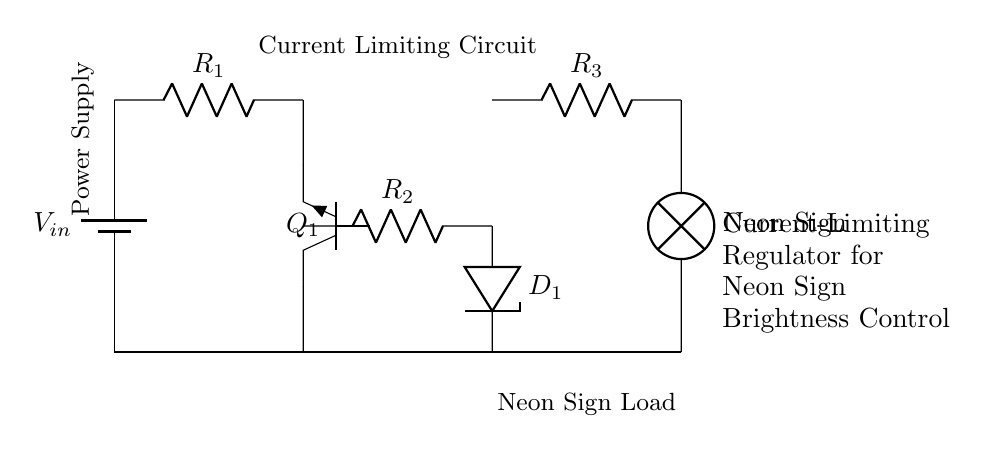What are the components used in the current-limiting regulator? The components include a battery, resistors, transistors, a zener diode, and a neon sign.
Answer: battery, resistors, transistor, zener diode, neon sign What is the role of resistor R1 in this circuit? Resistor R1 acts as a current limiting component to help control the amount of current flowing into the circuit, protecting other components from excessive current.
Answer: Current limiter What type of transistor is used in this circuit? The circuit features a NPN transistor, which allows the control of current flow from the collector to the emitter based on the base voltage.
Answer: NPN How does the zener diode function in this circuit? The zener diode (D1) regulates the voltage across it to a specific value, providing a stable reference voltage for controlling the current through the neon sign.
Answer: Voltage regulation What happens if the resistance R3 is decreased? Decreasing the resistance R3 would increase the current flowing through the neon sign, potentially causing it to become brighter or exceed its maximum current rating, which could damage the sign.
Answer: Increases current Why is a current-limiting regulator necessary for neon signs? Neon signs require specific current levels for optimal brightness and performance; a current-limiting regulator ensures that excess current does not flow, preventing damage and maintaining correct illumination.
Answer: To prevent damage What is the purpose of the neon sign in the circuit? The neon sign serves as the load in the circuit, where the regulated current produces illumination based on its design and specifications.
Answer: Load for illumination 